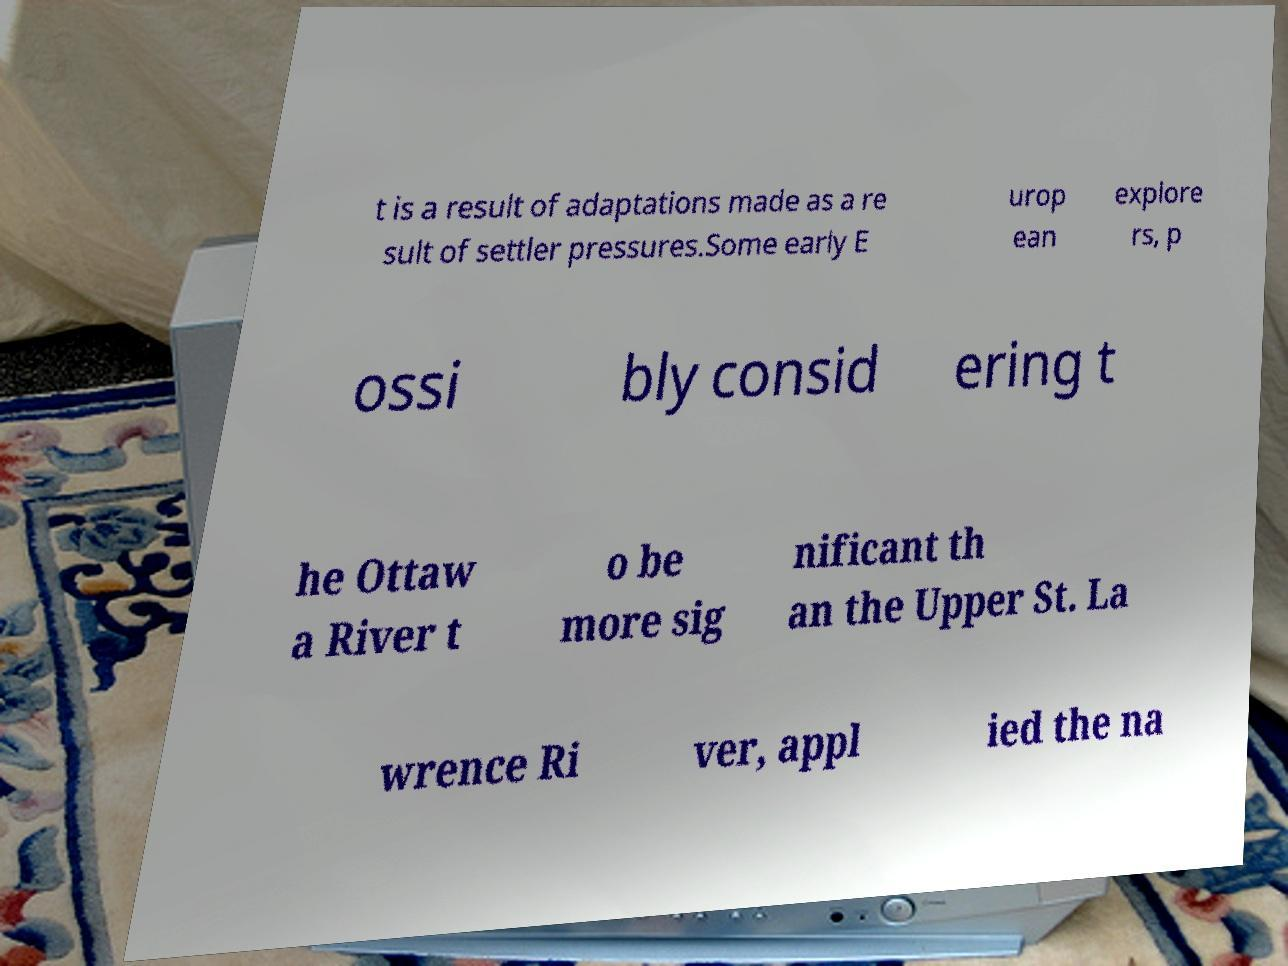Please identify and transcribe the text found in this image. t is a result of adaptations made as a re sult of settler pressures.Some early E urop ean explore rs, p ossi bly consid ering t he Ottaw a River t o be more sig nificant th an the Upper St. La wrence Ri ver, appl ied the na 